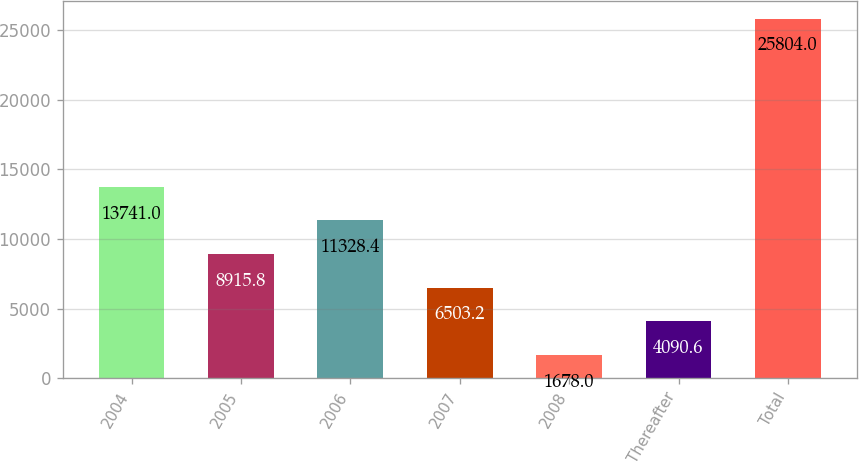<chart> <loc_0><loc_0><loc_500><loc_500><bar_chart><fcel>2004<fcel>2005<fcel>2006<fcel>2007<fcel>2008<fcel>Thereafter<fcel>Total<nl><fcel>13741<fcel>8915.8<fcel>11328.4<fcel>6503.2<fcel>1678<fcel>4090.6<fcel>25804<nl></chart> 